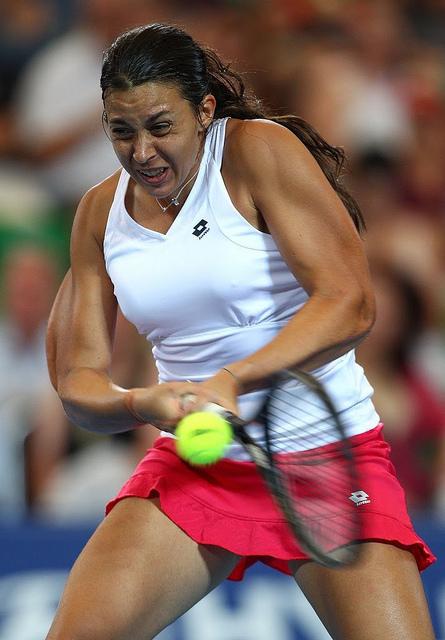What is on the women's head?
Answer briefly. Hair. Does this woman work out?
Keep it brief. Yes. Which color is the woman's top?
Quick response, please. White. What does the woman have on her head?
Quick response, please. Hair. Is the woman's hair long?
Give a very brief answer. Yes. What game is she playing?
Short answer required. Tennis. 